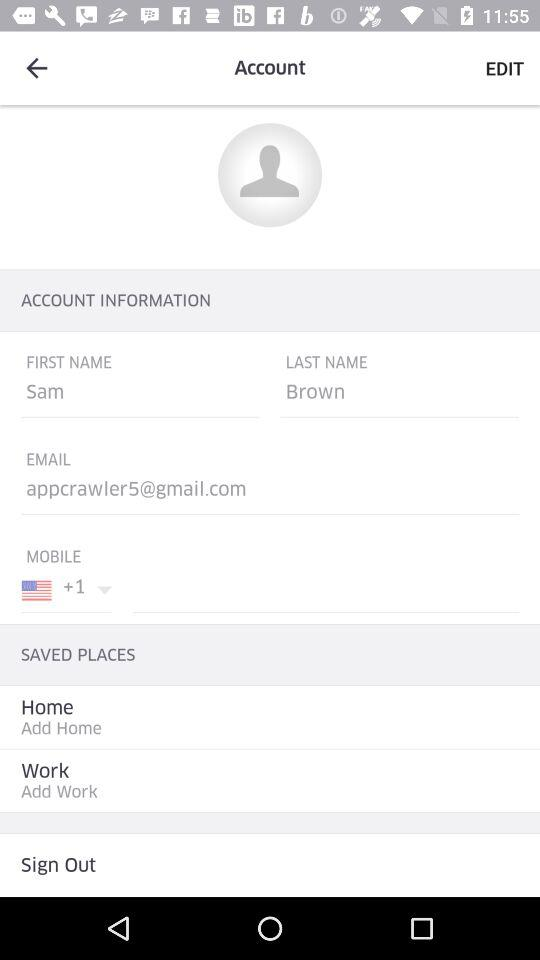How many items are there in the saved places section?
Answer the question using a single word or phrase. 2 